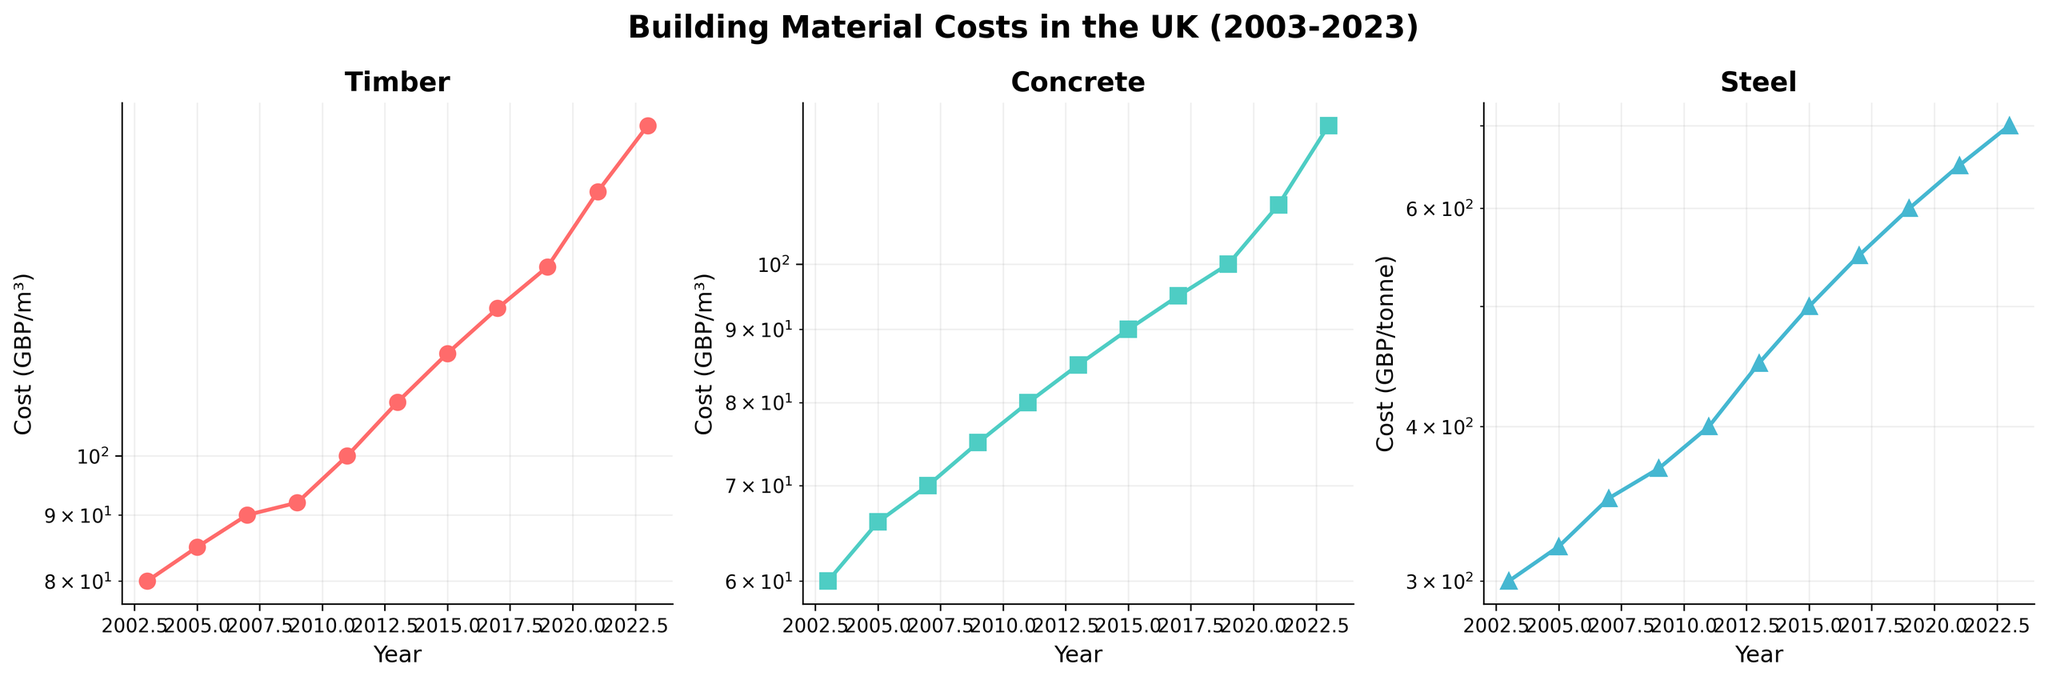What are the titles of the three subplots? The titles of the subplots are visible at the top of each subplot. They are displayed prominently and indicate the type of building material the plot refers to.
Answer: Timber, Concrete, Steel Which building material experienced the highest cost increase in absolute terms from 2003 to 2023? To determine this, look at the cost values for 2003 and 2023 for each material in the subplots. Calculate the difference for each material: Timber (180-80), Concrete (125-60), and Steel (700-300). Timber increased by 100 GBP/m³, Concrete by 65 GBP/m³, and Steel by 400 GBP/tonne.
Answer: Steel How does the cost of Concrete in 2013 compare to the cost of Timber in 2015? Inspect the subplots to find the costs for Concrete in 2013 and Timber in 2015. The values are 85 GBP/m³ for Concrete in 2013 and 120 GBP/m³ for Timber in 2015.
Answer: The cost of Timber in 2015 is higher By how much did the cost of Timber increase between 2019 and 2023? Look at the Timber subplot and find the cost values for 2019 and 2023: 140 GBP/m³ in 2019 and 180 GBP/m³ in 2023. Subtract the 2019 value from the 2023 value (180 - 140).
Answer: 40 GBP/m³ Which year had the same or nearly the same cost for both Timber and Concrete? Compare the costs year by year for Timber and Concrete across the subplots to find a year where the values are close. In 2003, Timber cost 80 GBP/m³ and Concrete cost 60 GBP/m³, which is reasonably close compared to other years.
Answer: 2003 What is the average cost of Steel over the two decades shown? Summarize the Steel costs displayed in the subplot and find their average. Add all the data points for Steel and divide by the number of data points: (300 + 320 + 350 + 370 + 400 + 450 + 500 + 550 + 600 + 650 + 700)/11.
Answer: 463.64 GBP/tonne During which period did Concrete see its fastest increase in costs? Examine the Concrete plot and identify the period with the steepest increase by comparing the slopes of the line segments. From 2019 to 2023, Concrete increased from 100 GBP/m³ to 125 GBP/m³, which is the steepest among the periods.
Answer: 2019-2023 Have any of the materials shown a decrease in price at any point over the two decades? To check for decreases, inspect each subplot for any downward trends in the data points. All subplots show a consistent increase with no visible decreases.
Answer: No Which material had the highest cost at the earliest year shown, and what was the cost? Look at the costs for all three materials in 2003 from the respective subplots. Timber (80 GBP/m³), Concrete (60 GBP/m³), and Steel (300 GBP/tonne). Steel had the highest cost.
Answer: Steel, 300 GBP/tonne 